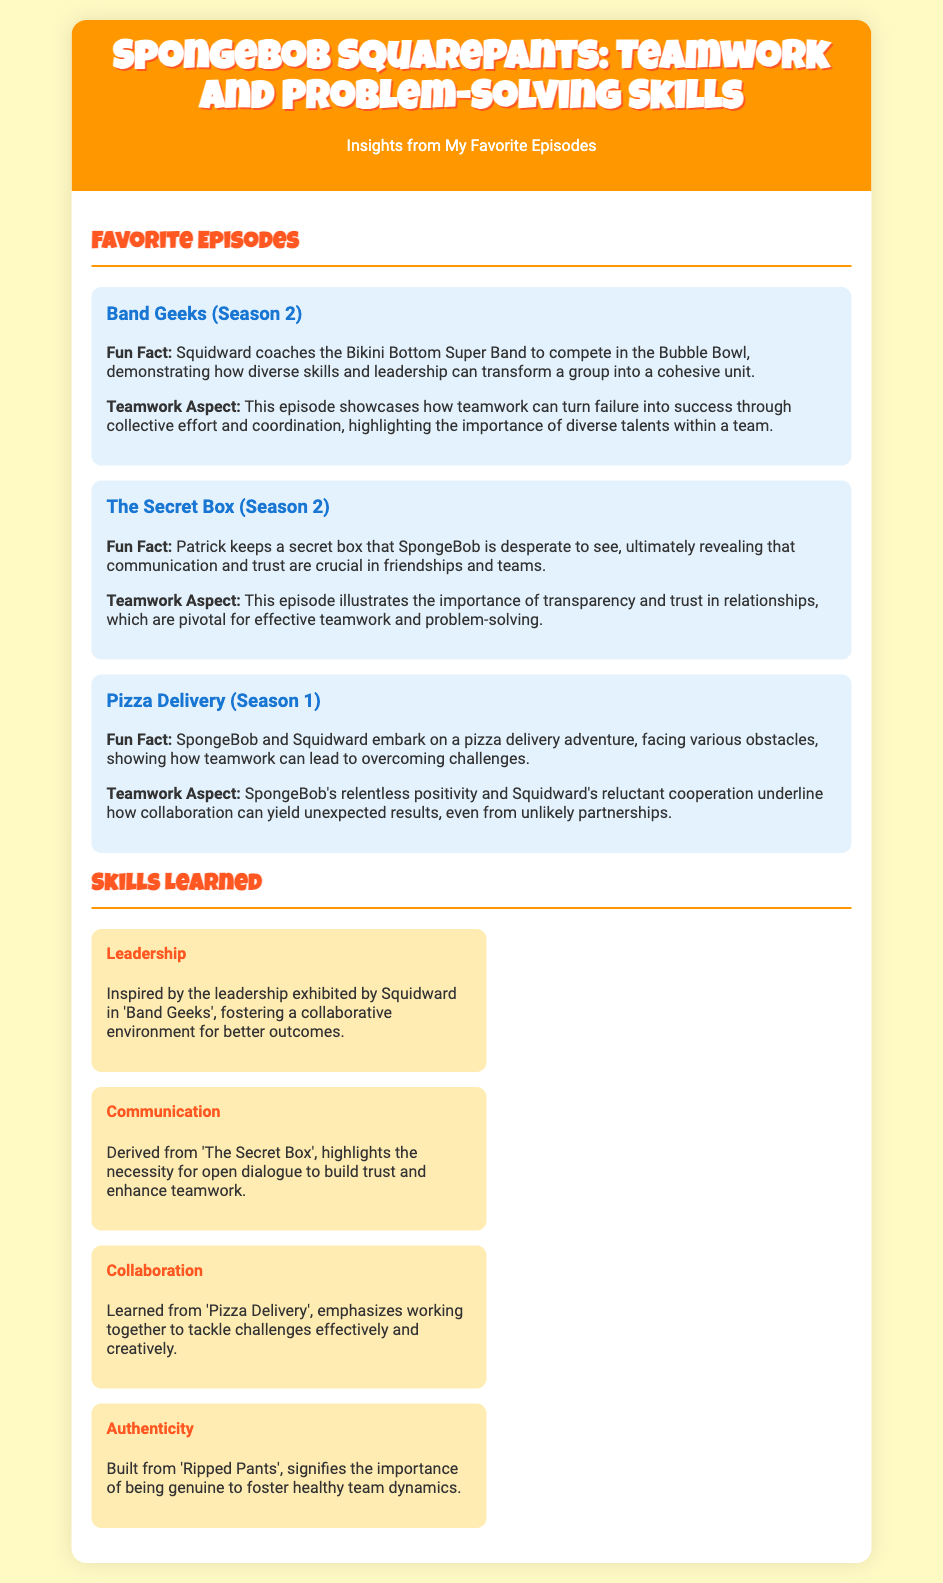What is the title of the document? The title of the document is presented in the header of the document.
Answer: SpongeBob SquarePants: Teamwork and Problem-Solving Skills Which episode features Squidward coaching a band? This information is found in the section discussing favorite episodes, particularly where 'Band Geeks' is mentioned.
Answer: Band Geeks What lesson does 'The Secret Box' episode teach? The lesson is included in the teamwork aspect associated with 'The Secret Box'.
Answer: Communication and trust How many favorite episodes are listed in the document? The number of favorite episodes can be counted in the section under "Favorite Episodes".
Answer: Three Which skill is inspired by 'Band Geeks'? The skills learned are detailed under the "Skills Learned" section, associating them with specific episodes.
Answer: Leadership What does 'Pizza Delivery' emphasize? This is derived from the teamwork aspect related to the episode mentioned in the document.
Answer: Collaboration Which episode is listed first? The order of episodes is sequential in the "Favorite Episodes" section.
Answer: Band Geeks What color is the background of the document? The background color is specified in the body style of the document.
Answer: Light yellow How is the "content" area formatted? The content area formatting can be inferred from its description in the document structure.
Answer: Padding and rounded corners 